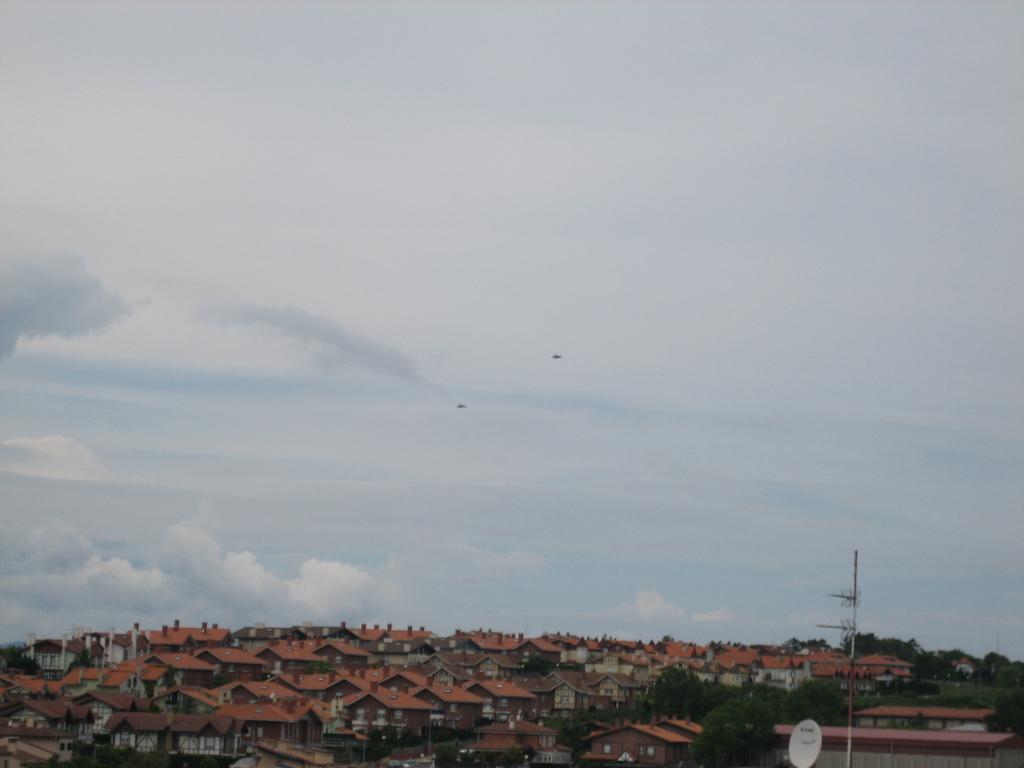Could you give a brief overview of what you see in this image? At the bottom there are houses, trees and a current pole. Sky is cloudy. In the center of the picture there are birds. 